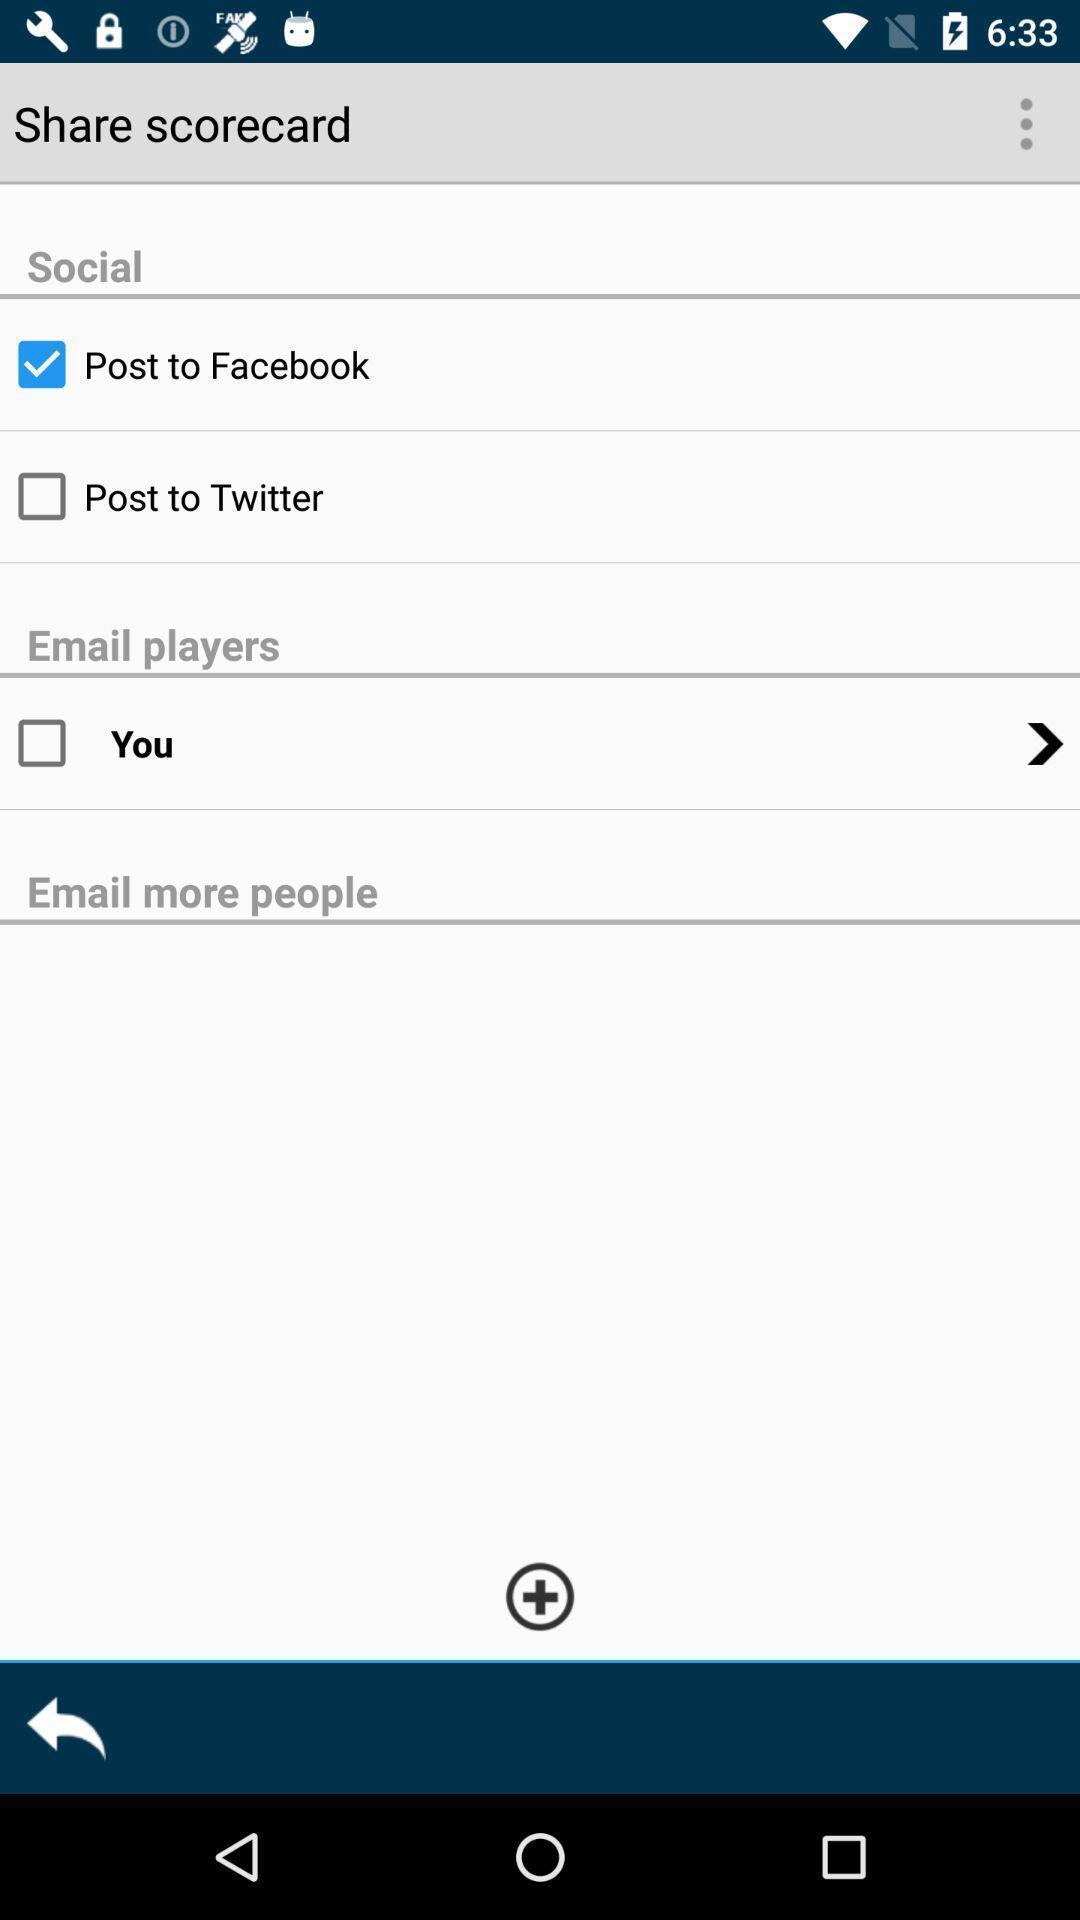Give me a narrative description of this picture. Screen showing the input fields for sharing. 